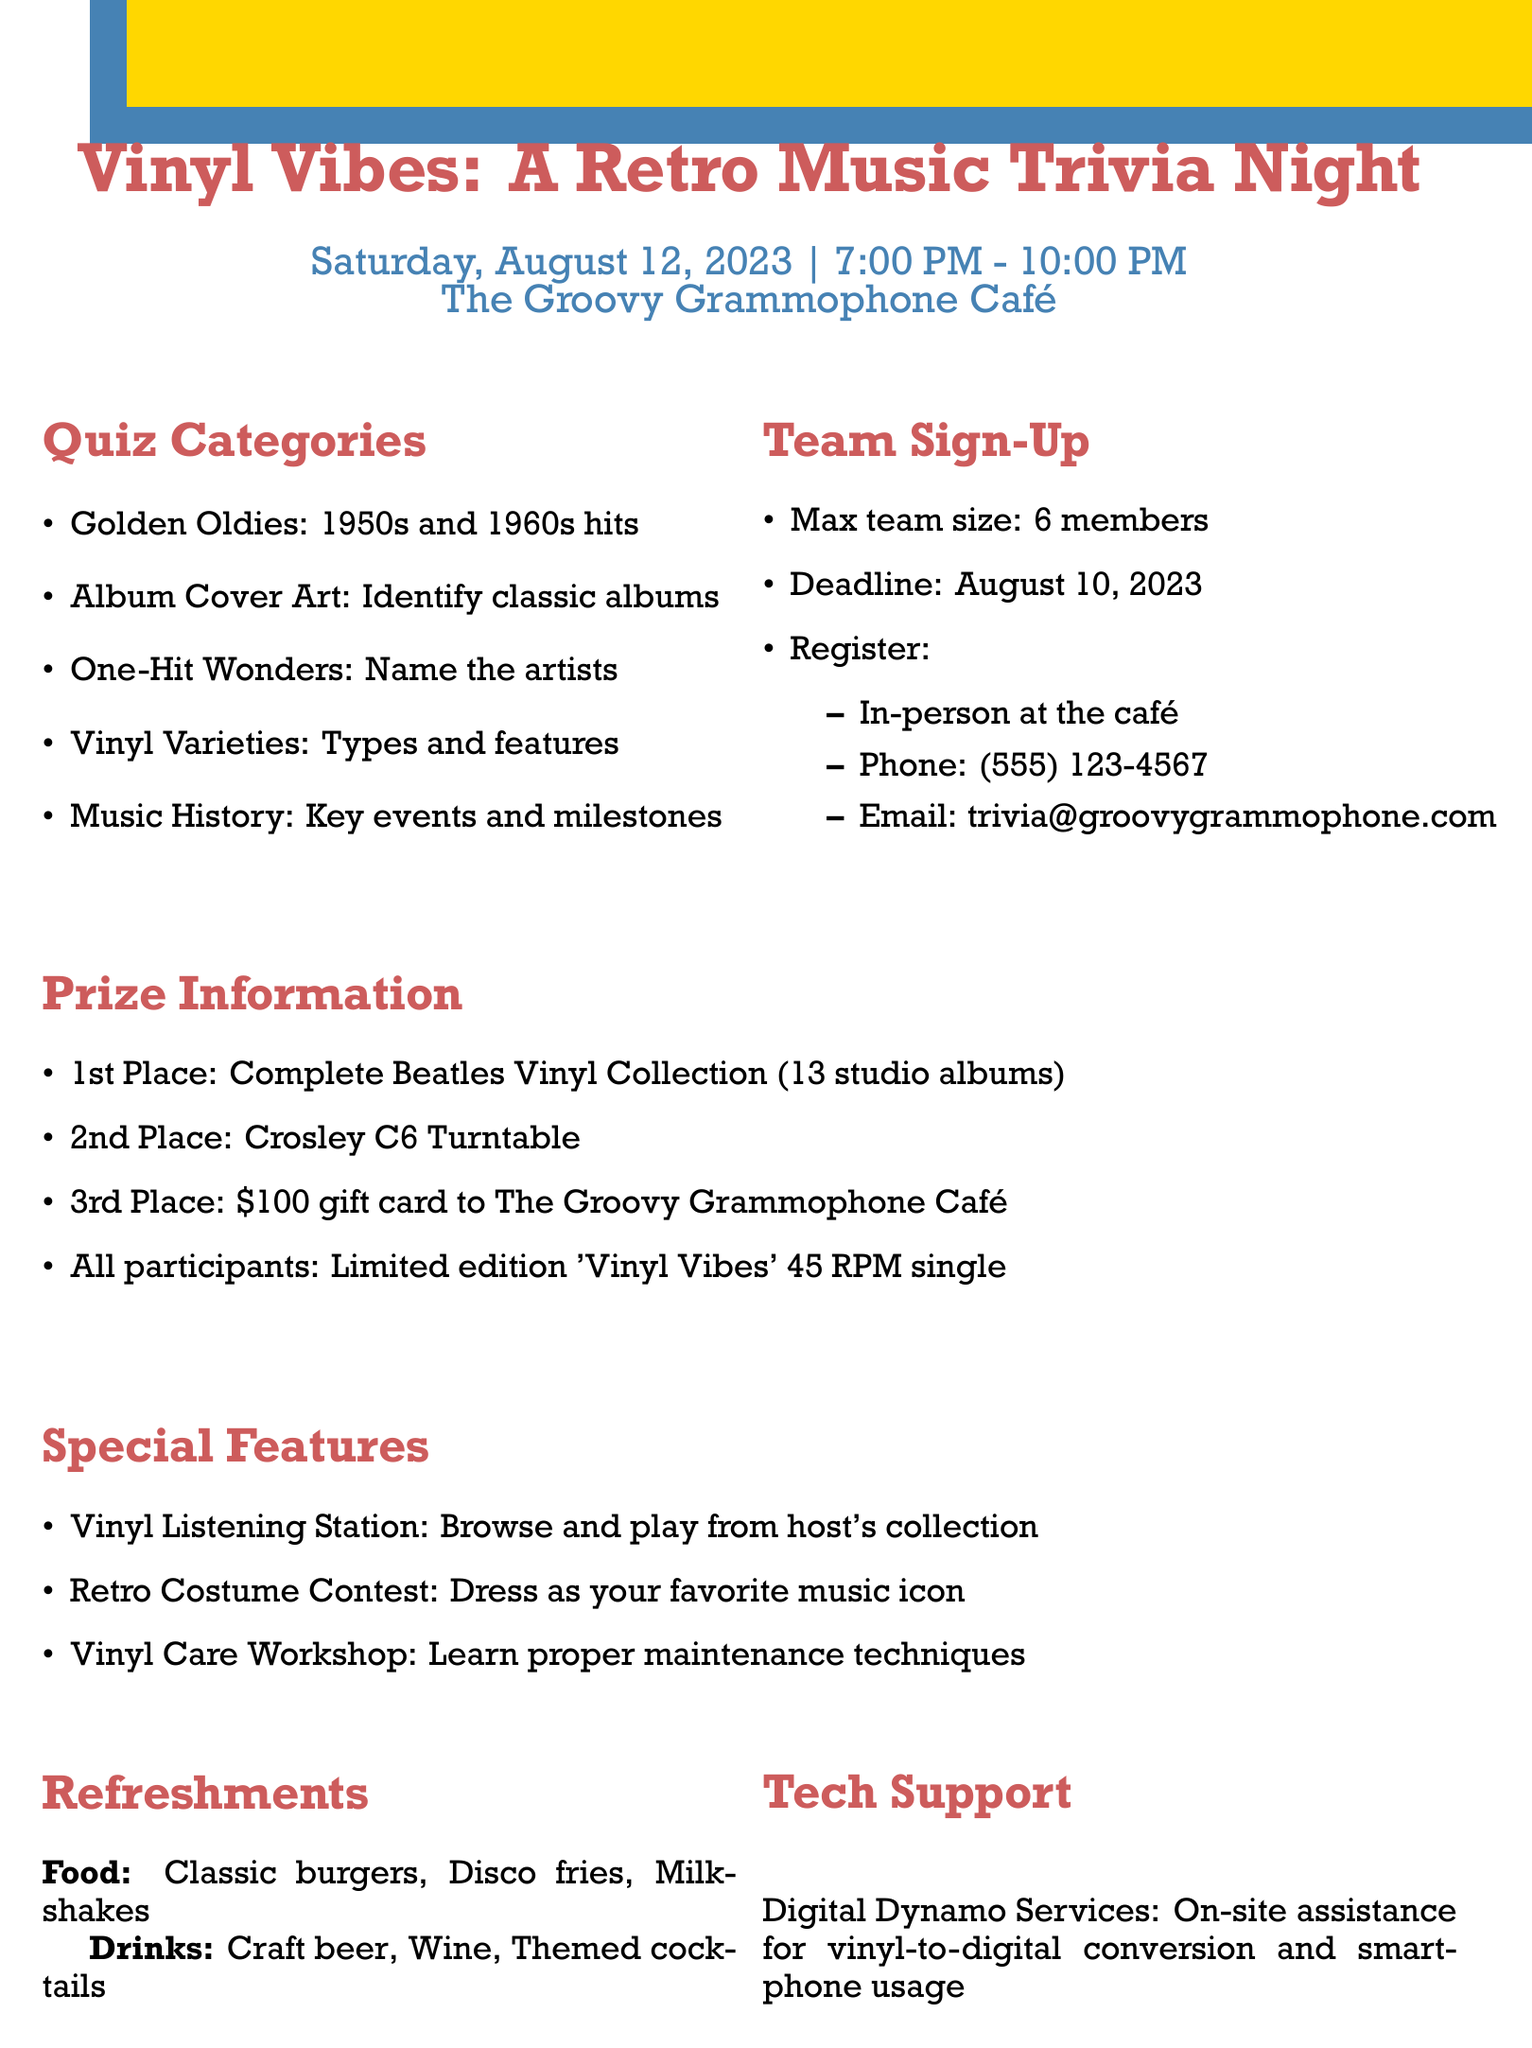What is the name of the event? The name of the event is stated at the top of the document.
Answer: Vinyl Vibes: A Retro Music Trivia Night What is the date of the trivia night? The date is mentioned along with the event name.
Answer: Saturday, August 12, 2023 How many quiz categories are there? By counting the listed quiz categories in the document, we can determine the total.
Answer: 5 What is the prize for first place? The first place prize is specifically mentioned in the prize information section.
Answer: Complete Beatles Vinyl Collection (13 studio albums) What is the registration deadline for team sign-up? The document clearly states the last date to register for the trivia night event.
Answer: August 10, 2023 What is the maximum team size allowed? This piece of information is found in the team sign-up section.
Answer: 6 Who is the sponsor of the second place prize? The sponsor of the second place prize is detailed in the prize information section.
Answer: RetroSound Electronics What types of food will be served at the event? The food options are listed under the refreshments section of the document.
Answer: Classic diner-style burgers, Disco fries, Soda shop milkshakes What assistance does Digital Dynamo Services provide? The document describes the services offered by Digital Dynamo Services in the tech support section.
Answer: Converting vinyl to digital formats 